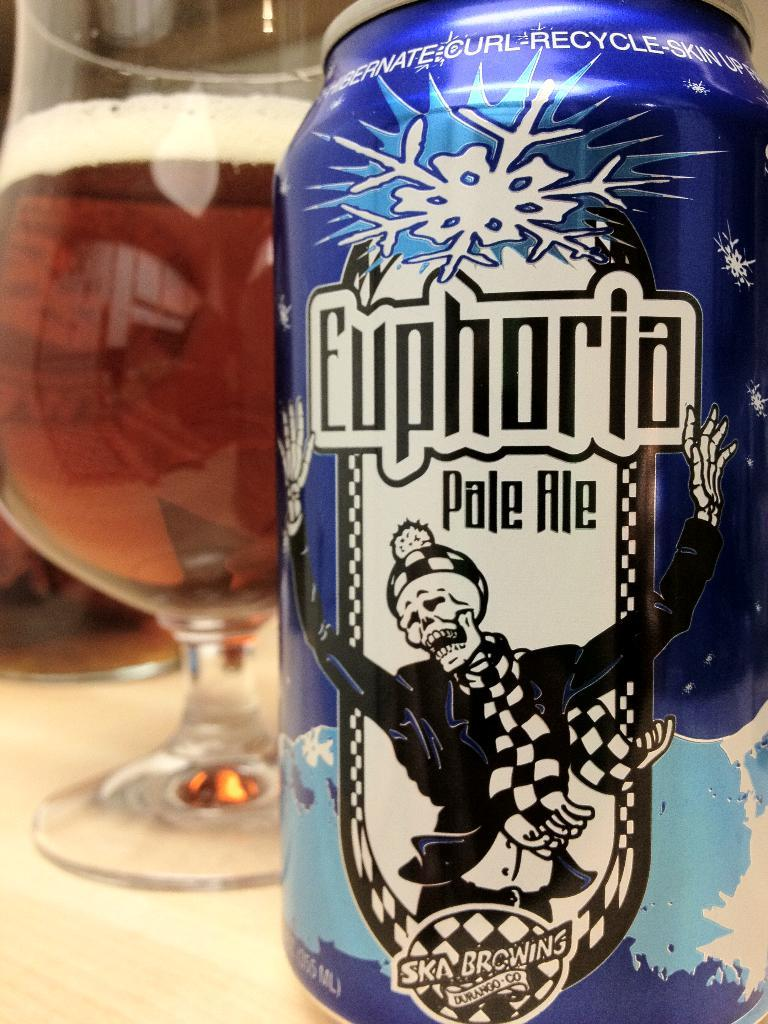Provide a one-sentence caption for the provided image. A blue can of Euphoria pale ale sits next to a glass. 